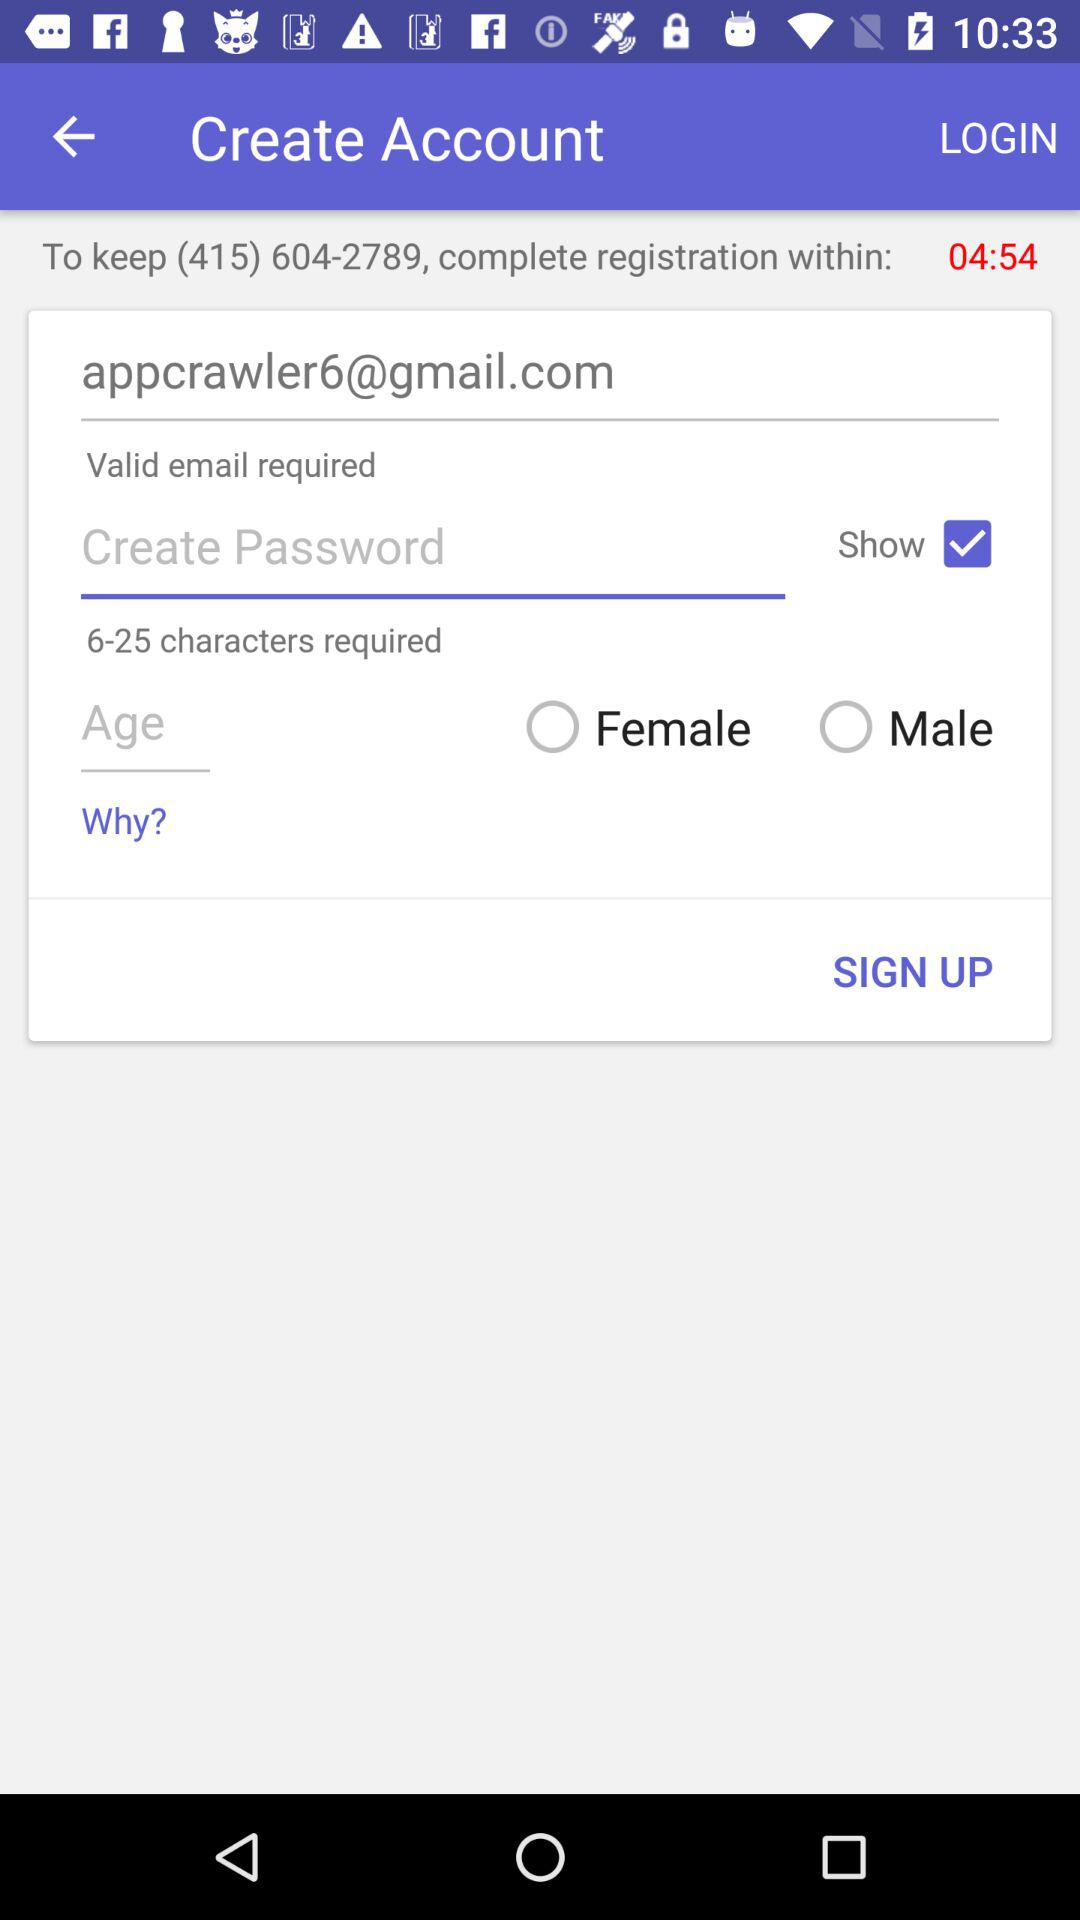What is the status of the show? The status is on. 